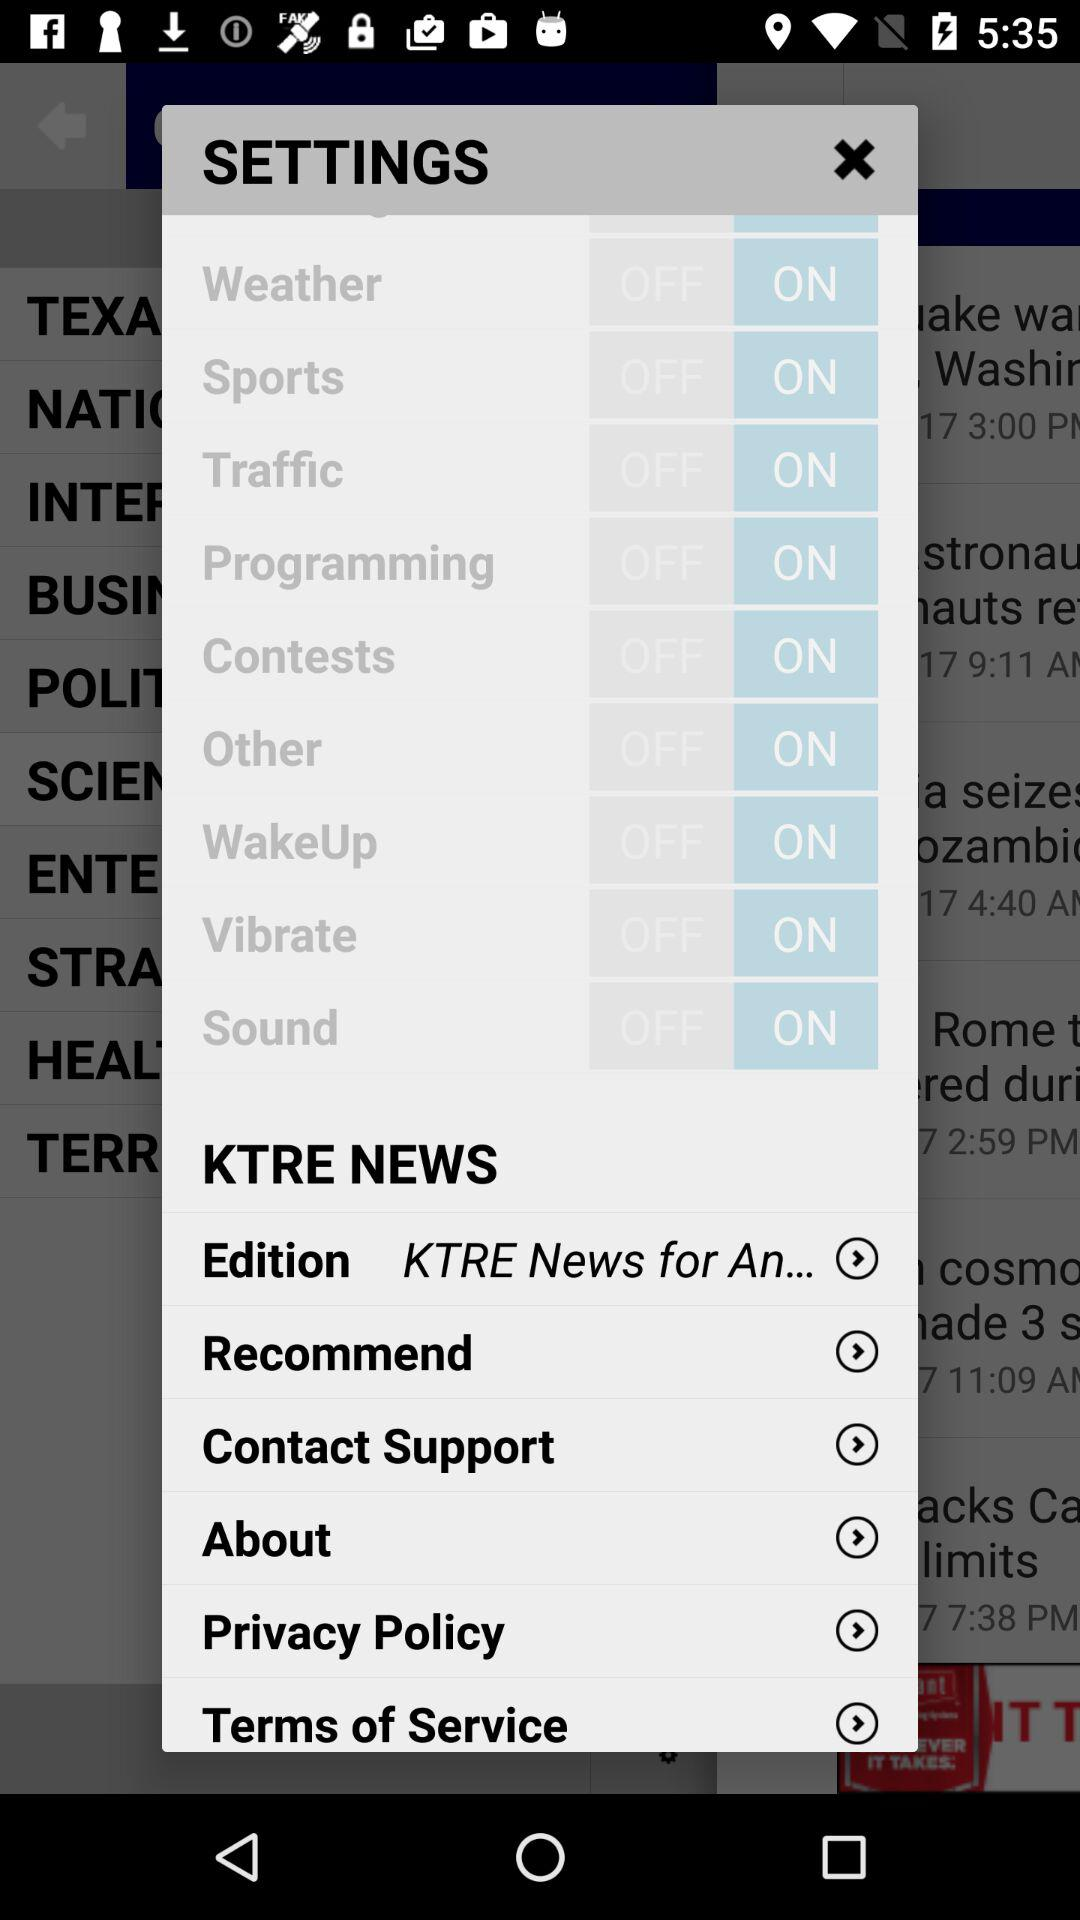What is the status of the "Vibrate" setting? The status is "on". 